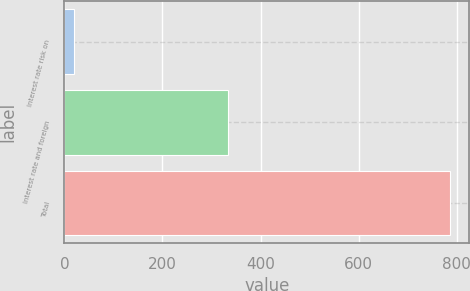Convert chart to OTSL. <chart><loc_0><loc_0><loc_500><loc_500><bar_chart><fcel>Interest rate risk on<fcel>Interest rate and foreign<fcel>Total<nl><fcel>19<fcel>333<fcel>787<nl></chart> 